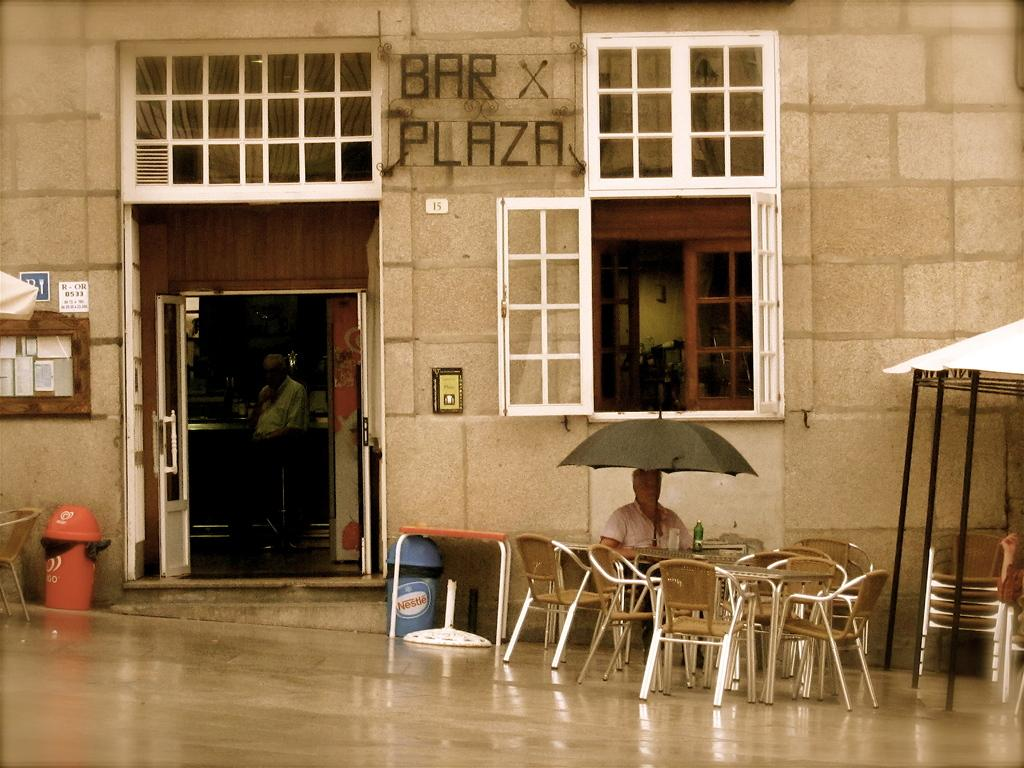What is the man in the image doing? The man is sitting in a chair at a table. What object is the man holding in the image? The man is holding an umbrella. What is the name of the building in the image? The building in the image is titled "Brax Plaza". What architectural features can be seen in the image? There is a door and a window in the image. What type of food is the man's mom bringing him in the image? There is no mention of food or the man's mom in the image. 